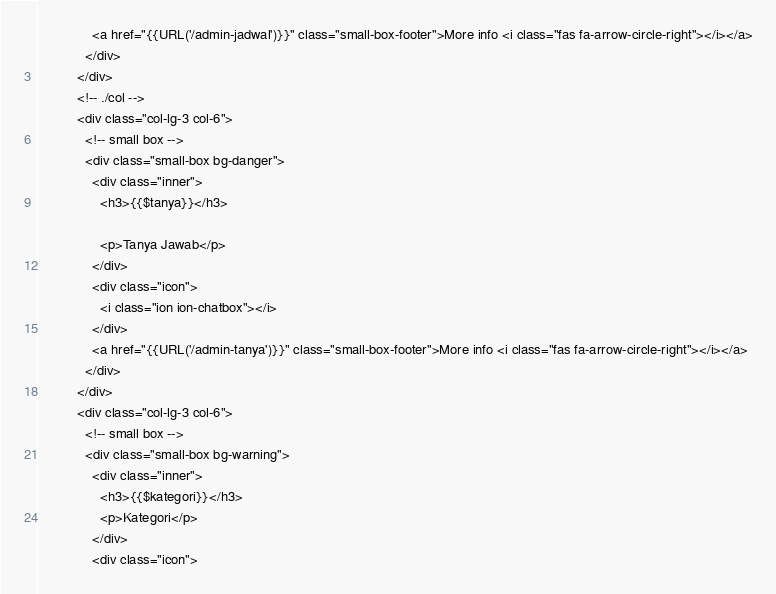Convert code to text. <code><loc_0><loc_0><loc_500><loc_500><_PHP_>              <a href="{{URL('/admin-jadwal')}}" class="small-box-footer">More info <i class="fas fa-arrow-circle-right"></i></a>
            </div>
          </div>
          <!-- ./col -->
          <div class="col-lg-3 col-6">
            <!-- small box -->
            <div class="small-box bg-danger">
              <div class="inner">
                <h3>{{$tanya}}</h3>

                <p>Tanya Jawab</p>
              </div>
              <div class="icon">
                <i class="ion ion-chatbox"></i>
              </div>
              <a href="{{URL('/admin-tanya')}}" class="small-box-footer">More info <i class="fas fa-arrow-circle-right"></i></a>
            </div>
          </div>
          <div class="col-lg-3 col-6">
            <!-- small box -->
            <div class="small-box bg-warning">
              <div class="inner">
                <h3>{{$kategori}}</h3>
                <p>Kategori</p>
              </div>
              <div class="icon"></code> 